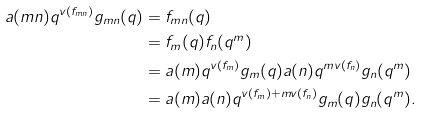<formula> <loc_0><loc_0><loc_500><loc_500>a ( m n ) q ^ { v ( f _ { m n } ) } g _ { m n } ( q ) & = f _ { m n } ( q ) \\ & = f _ { m } ( q ) f _ { n } ( q ^ { m } ) \\ & = a ( m ) q ^ { v ( f _ { m } ) } g _ { m } ( q ) a ( n ) q ^ { m v ( f _ { n } ) } g _ { n } ( q ^ { m } ) \\ & = a ( m ) a ( n ) q ^ { v ( f _ { m } ) + m v ( f _ { n } ) } g _ { m } ( q ) g _ { n } ( q ^ { m } ) .</formula> 